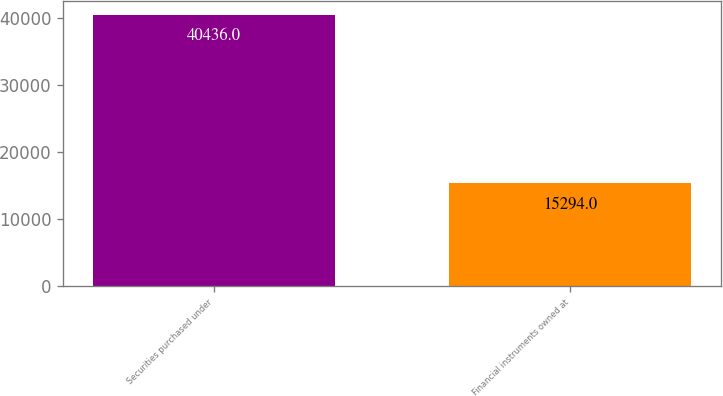Convert chart. <chart><loc_0><loc_0><loc_500><loc_500><bar_chart><fcel>Securities purchased under<fcel>Financial instruments owned at<nl><fcel>40436<fcel>15294<nl></chart> 